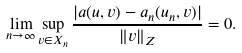<formula> <loc_0><loc_0><loc_500><loc_500>\lim _ { n \to \infty } \sup _ { v \in X _ { n } } \frac { | a ( u , v ) - a _ { n } ( u _ { n } , v ) | } { \| v \| _ { Z } } = 0 .</formula> 